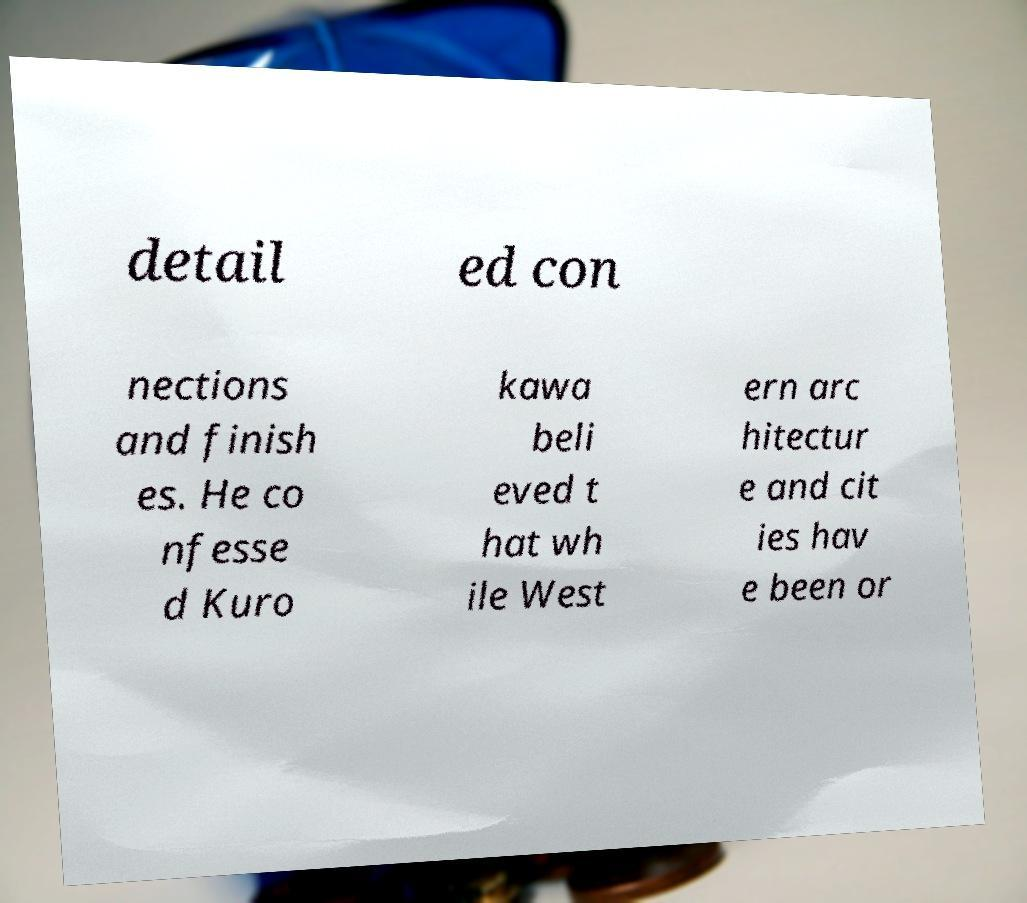There's text embedded in this image that I need extracted. Can you transcribe it verbatim? detail ed con nections and finish es. He co nfesse d Kuro kawa beli eved t hat wh ile West ern arc hitectur e and cit ies hav e been or 